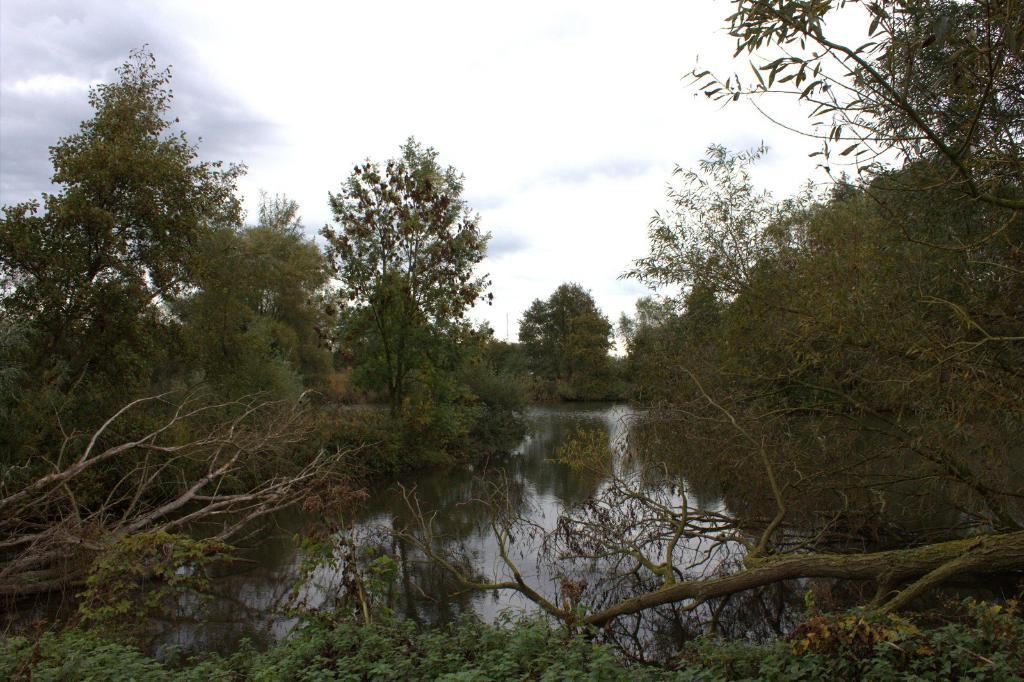What is located at the bottom of the image? There are trees and water at the bottom of the image. What can be seen in the background of the image? There are trees and clouds in the sky in the background of the image. How many dogs are playing with a toy wrench in the image? There are no dogs or toy wrenches present in the image. 